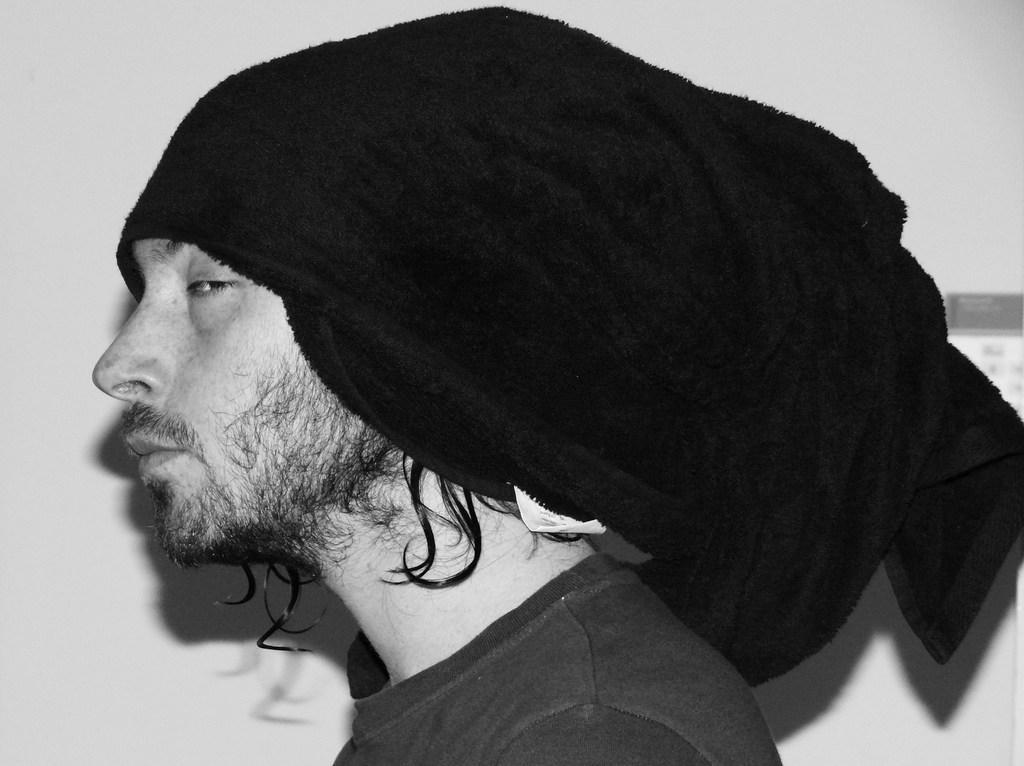In one or two sentences, can you explain what this image depicts? In this picture we can see a person and we can see a wall in the background. 